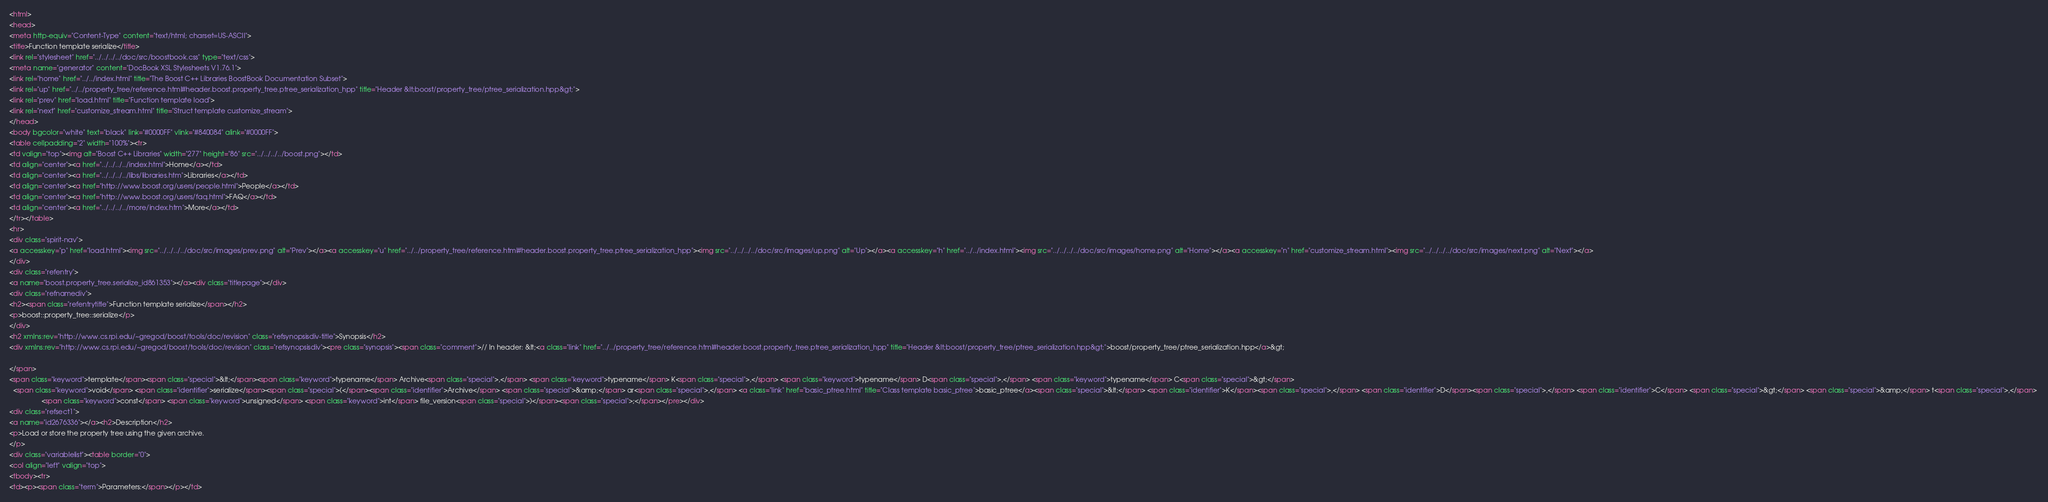Convert code to text. <code><loc_0><loc_0><loc_500><loc_500><_HTML_><html>
<head>
<meta http-equiv="Content-Type" content="text/html; charset=US-ASCII">
<title>Function template serialize</title>
<link rel="stylesheet" href="../../../../doc/src/boostbook.css" type="text/css">
<meta name="generator" content="DocBook XSL Stylesheets V1.76.1">
<link rel="home" href="../../index.html" title="The Boost C++ Libraries BoostBook Documentation Subset">
<link rel="up" href="../../property_tree/reference.html#header.boost.property_tree.ptree_serialization_hpp" title="Header &lt;boost/property_tree/ptree_serialization.hpp&gt;">
<link rel="prev" href="load.html" title="Function template load">
<link rel="next" href="customize_stream.html" title="Struct template customize_stream">
</head>
<body bgcolor="white" text="black" link="#0000FF" vlink="#840084" alink="#0000FF">
<table cellpadding="2" width="100%"><tr>
<td valign="top"><img alt="Boost C++ Libraries" width="277" height="86" src="../../../../boost.png"></td>
<td align="center"><a href="../../../../index.html">Home</a></td>
<td align="center"><a href="../../../../libs/libraries.htm">Libraries</a></td>
<td align="center"><a href="http://www.boost.org/users/people.html">People</a></td>
<td align="center"><a href="http://www.boost.org/users/faq.html">FAQ</a></td>
<td align="center"><a href="../../../../more/index.htm">More</a></td>
</tr></table>
<hr>
<div class="spirit-nav">
<a accesskey="p" href="load.html"><img src="../../../../doc/src/images/prev.png" alt="Prev"></a><a accesskey="u" href="../../property_tree/reference.html#header.boost.property_tree.ptree_serialization_hpp"><img src="../../../../doc/src/images/up.png" alt="Up"></a><a accesskey="h" href="../../index.html"><img src="../../../../doc/src/images/home.png" alt="Home"></a><a accesskey="n" href="customize_stream.html"><img src="../../../../doc/src/images/next.png" alt="Next"></a>
</div>
<div class="refentry">
<a name="boost.property_tree.serialize_id861353"></a><div class="titlepage"></div>
<div class="refnamediv">
<h2><span class="refentrytitle">Function template serialize</span></h2>
<p>boost::property_tree::serialize</p>
</div>
<h2 xmlns:rev="http://www.cs.rpi.edu/~gregod/boost/tools/doc/revision" class="refsynopsisdiv-title">Synopsis</h2>
<div xmlns:rev="http://www.cs.rpi.edu/~gregod/boost/tools/doc/revision" class="refsynopsisdiv"><pre class="synopsis"><span class="comment">// In header: &lt;<a class="link" href="../../property_tree/reference.html#header.boost.property_tree.ptree_serialization_hpp" title="Header &lt;boost/property_tree/ptree_serialization.hpp&gt;">boost/property_tree/ptree_serialization.hpp</a>&gt;

</span>
<span class="keyword">template</span><span class="special">&lt;</span><span class="keyword">typename</span> Archive<span class="special">,</span> <span class="keyword">typename</span> K<span class="special">,</span> <span class="keyword">typename</span> D<span class="special">,</span> <span class="keyword">typename</span> C<span class="special">&gt;</span> 
  <span class="keyword">void</span> <span class="identifier">serialize</span><span class="special">(</span><span class="identifier">Archive</span> <span class="special">&amp;</span> ar<span class="special">,</span> <a class="link" href="basic_ptree.html" title="Class template basic_ptree">basic_ptree</a><span class="special">&lt;</span> <span class="identifier">K</span><span class="special">,</span> <span class="identifier">D</span><span class="special">,</span> <span class="identifier">C</span> <span class="special">&gt;</span> <span class="special">&amp;</span> t<span class="special">,</span> 
                 <span class="keyword">const</span> <span class="keyword">unsigned</span> <span class="keyword">int</span> file_version<span class="special">)</span><span class="special">;</span></pre></div>
<div class="refsect1">
<a name="id2676336"></a><h2>Description</h2>
<p>Load or store the property tree using the given archive. 
</p>
<div class="variablelist"><table border="0">
<col align="left" valign="top">
<tbody><tr>
<td><p><span class="term">Parameters:</span></p></td></code> 